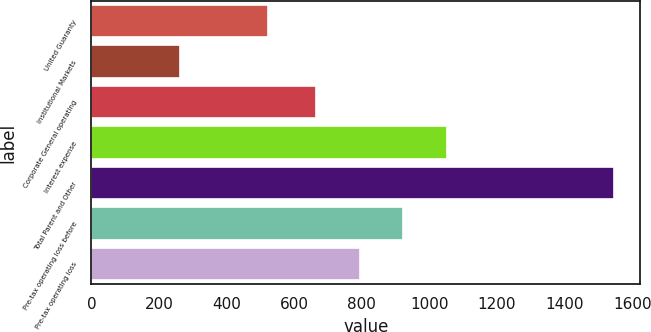Convert chart to OTSL. <chart><loc_0><loc_0><loc_500><loc_500><bar_chart><fcel>United Guaranty<fcel>Institutional Markets<fcel>Corporate General operating<fcel>Interest expense<fcel>Total Parent and Other<fcel>Pre-tax operating loss before<fcel>Pre-tax operating loss<nl><fcel>522<fcel>263<fcel>666<fcel>1051.2<fcel>1547<fcel>922.8<fcel>794.4<nl></chart> 